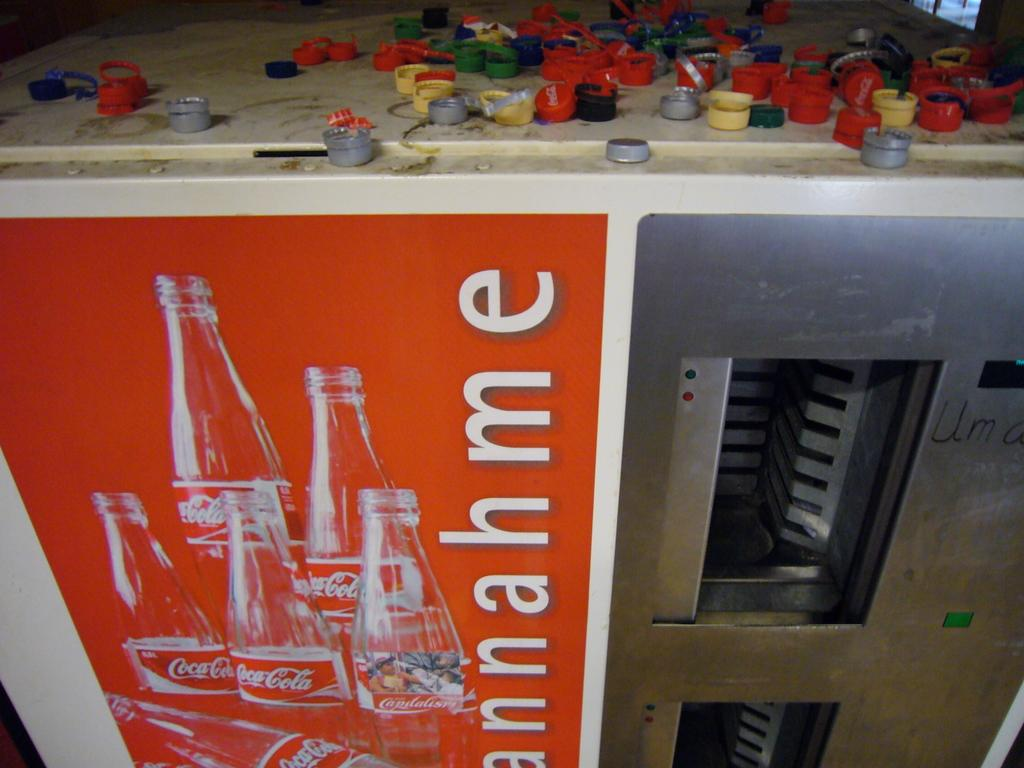<image>
Offer a succinct explanation of the picture presented. An old Coca Cola bottle machine littered with bottle caps. 